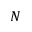Convert formula to latex. <formula><loc_0><loc_0><loc_500><loc_500>N</formula> 